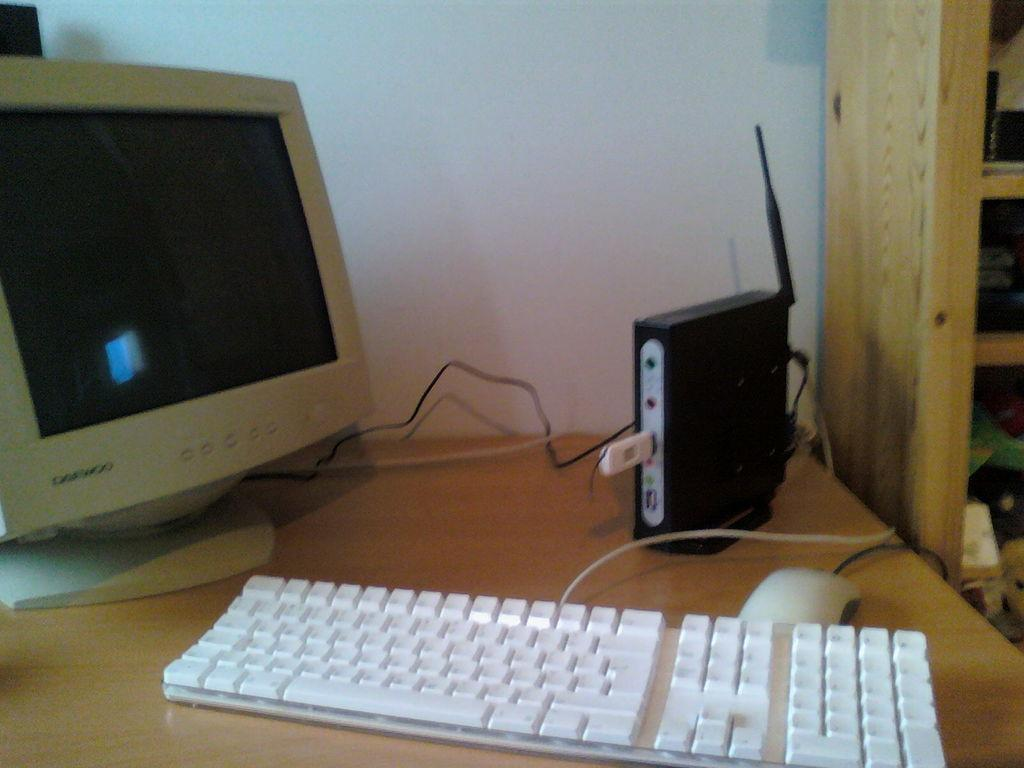What type of electronic device is visible in the image? There is a monitor and an electrical device in the image. What is used for input with the electronic device? There is a keyboard and a mouse in the image, which are used for input. Where are these objects located? All these objects are on a table. What can be seen in the background of the image? There is a wall and furniture in the background of the image. How many cords are connected to the electrical device in the image? There is no information about cords in the image, as the focus is on the objects themselves and not their connections. 